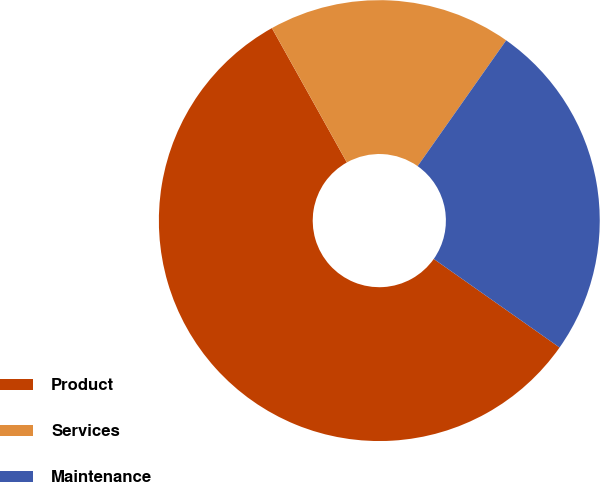Convert chart. <chart><loc_0><loc_0><loc_500><loc_500><pie_chart><fcel>Product<fcel>Services<fcel>Maintenance<nl><fcel>57.14%<fcel>17.86%<fcel>25.0%<nl></chart> 